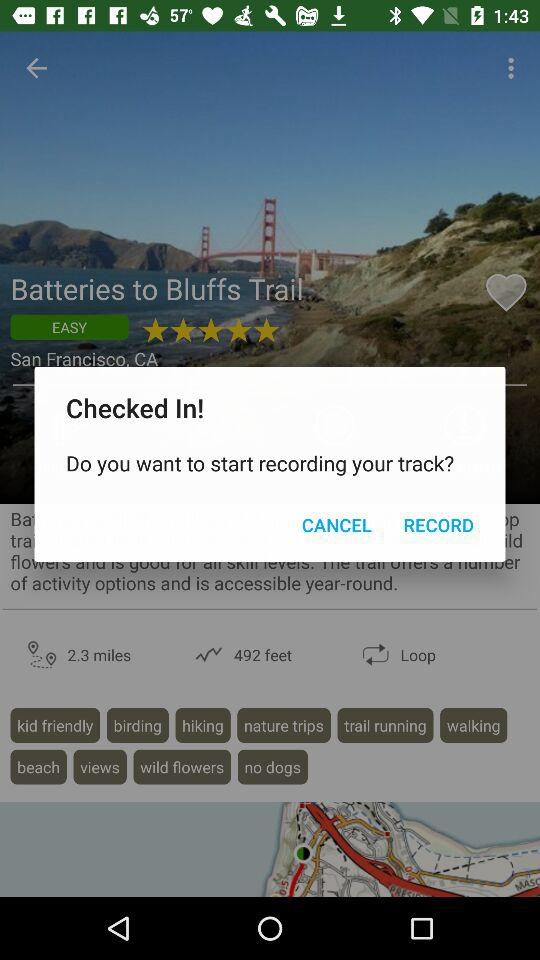What is the password?
When the provided information is insufficient, respond with <no answer>. <no answer> 